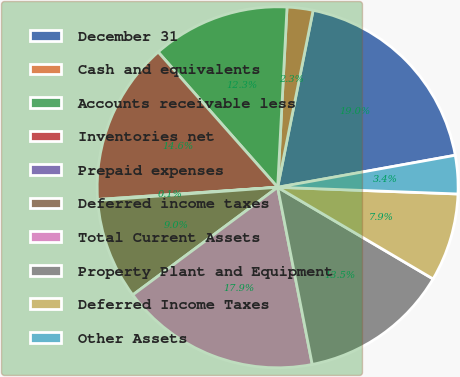Convert chart to OTSL. <chart><loc_0><loc_0><loc_500><loc_500><pie_chart><fcel>December 31<fcel>Cash and equivalents<fcel>Accounts receivable less<fcel>Inventories net<fcel>Prepaid expenses<fcel>Deferred income taxes<fcel>Total Current Assets<fcel>Property Plant and Equipment<fcel>Deferred Income Taxes<fcel>Other Assets<nl><fcel>19.01%<fcel>2.32%<fcel>12.34%<fcel>14.56%<fcel>0.09%<fcel>9.0%<fcel>17.9%<fcel>13.45%<fcel>7.89%<fcel>3.43%<nl></chart> 